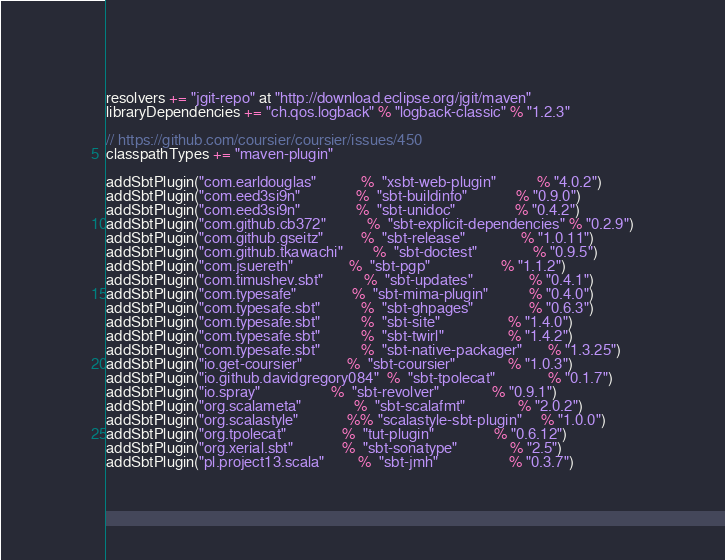Convert code to text. <code><loc_0><loc_0><loc_500><loc_500><_Scala_>resolvers += "jgit-repo" at "http://download.eclipse.org/jgit/maven"
libraryDependencies += "ch.qos.logback" % "logback-classic" % "1.2.3"

// https://github.com/coursier/coursier/issues/450
classpathTypes += "maven-plugin"

addSbtPlugin("com.earldouglas"            %  "xsbt-web-plugin"           % "4.0.2")
addSbtPlugin("com.eed3si9n"               %  "sbt-buildinfo"             % "0.9.0")
addSbtPlugin("com.eed3si9n"               %  "sbt-unidoc"                % "0.4.2")
addSbtPlugin("com.github.cb372"           %  "sbt-explicit-dependencies" % "0.2.9")
addSbtPlugin("com.github.gseitz"          %  "sbt-release"               % "1.0.11")
addSbtPlugin("com.github.tkawachi"        %  "sbt-doctest"               % "0.9.5")
addSbtPlugin("com.jsuereth"               %  "sbt-pgp"                   % "1.1.2")
addSbtPlugin("com.timushev.sbt"           %  "sbt-updates"               % "0.4.1")
addSbtPlugin("com.typesafe"               %  "sbt-mima-plugin"           % "0.4.0")
addSbtPlugin("com.typesafe.sbt"           %  "sbt-ghpages"               % "0.6.3")
addSbtPlugin("com.typesafe.sbt"           %  "sbt-site"                  % "1.4.0")
addSbtPlugin("com.typesafe.sbt"           %  "sbt-twirl"                 % "1.4.2")
addSbtPlugin("com.typesafe.sbt"           %  "sbt-native-packager"       % "1.3.25")
addSbtPlugin("io.get-coursier"            %  "sbt-coursier"              % "1.0.3")
addSbtPlugin("io.github.davidgregory084"  %  "sbt-tpolecat"              % "0.1.7")
addSbtPlugin("io.spray"                   %  "sbt-revolver"              % "0.9.1")
addSbtPlugin("org.scalameta"              %  "sbt-scalafmt"              % "2.0.2")
addSbtPlugin("org.scalastyle"             %% "scalastyle-sbt-plugin"     % "1.0.0")
addSbtPlugin("org.tpolecat"               %  "tut-plugin"                % "0.6.12")
addSbtPlugin("org.xerial.sbt"             %  "sbt-sonatype"              % "2.5")
addSbtPlugin("pl.project13.scala"         %  "sbt-jmh"                   % "0.3.7")
</code> 